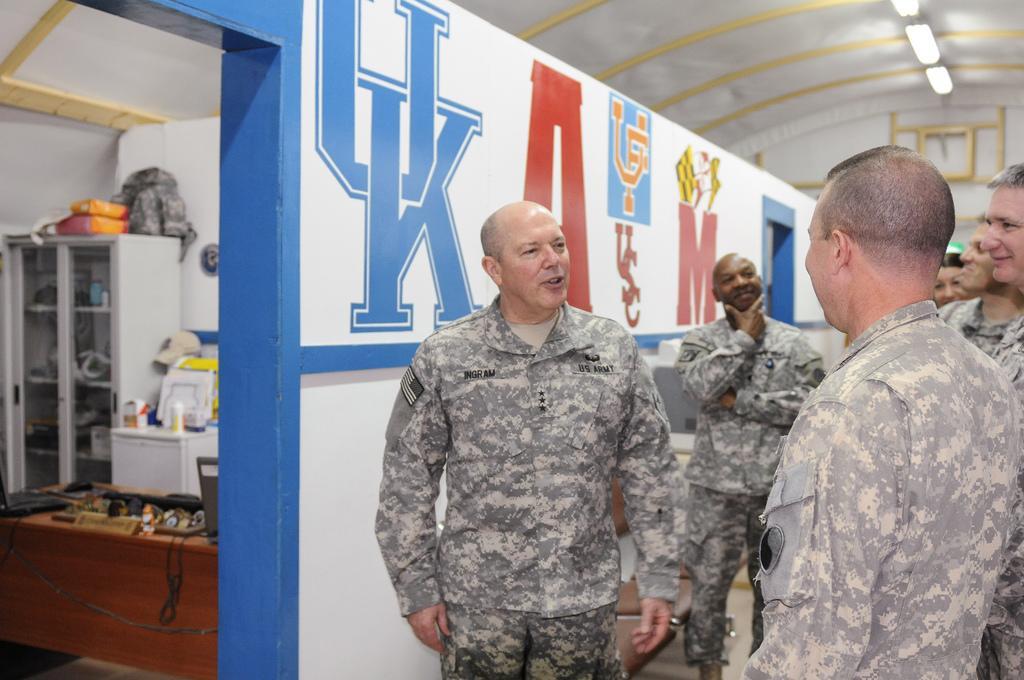How would you summarize this image in a sentence or two? To the right side of the image there are people standing wearing a uniform. To the left side of the image there is a room in which there is a shelf. There are other objects. There is a table. At the top of the image there is a ceiling with lights. 